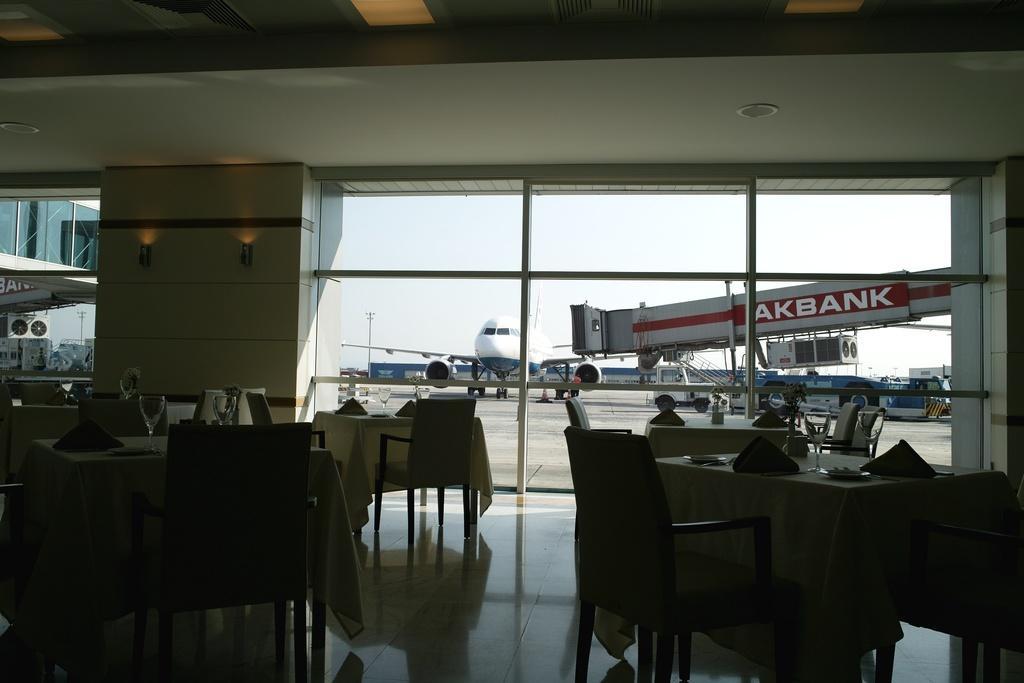Could you give a brief overview of what you see in this image? In the image it looks like a restaurant there are many empty tables and chairs, behind them there are windows and behind the windows there are aircrafts. 